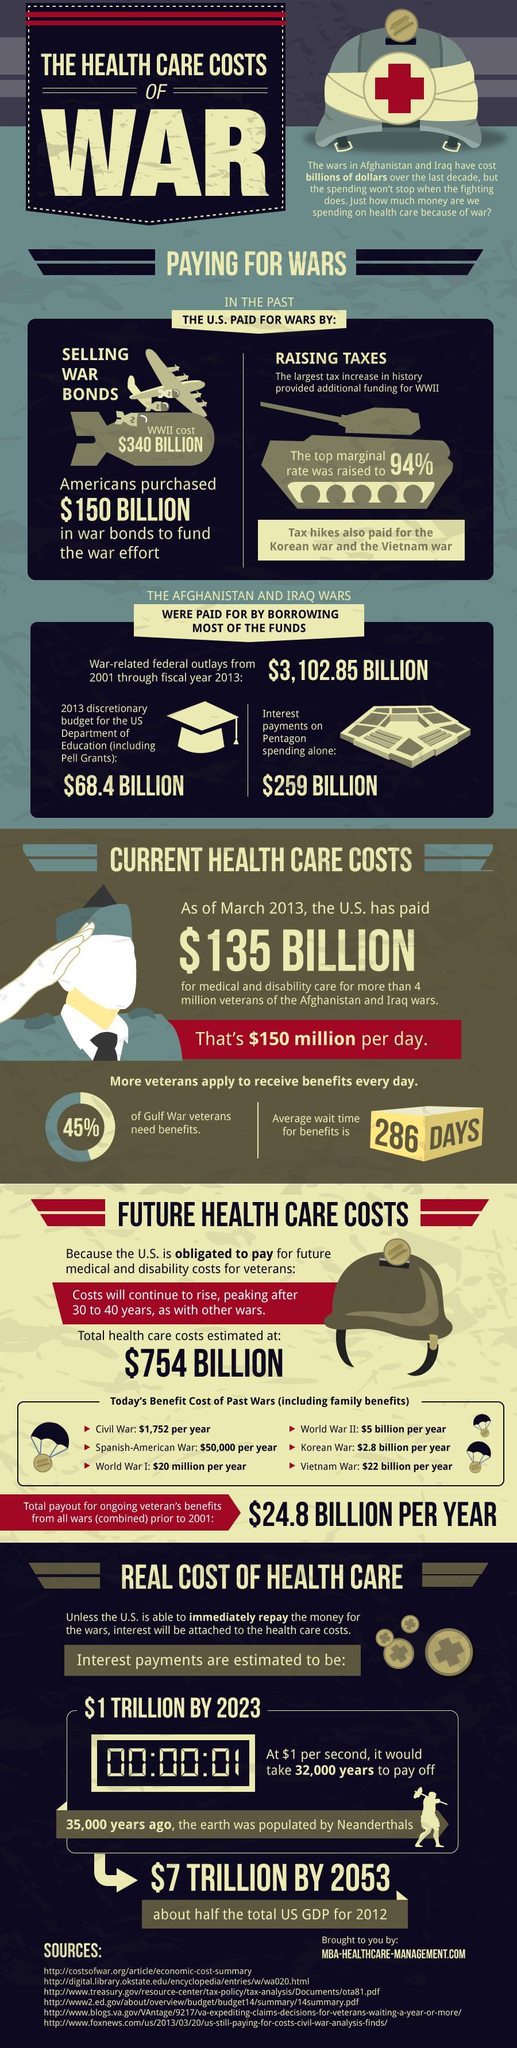What was the 2013 budget for department of education?
Answer the question with a short phrase. $68.4 billion What was the interest payments on Pentagon spending? $259 billion 